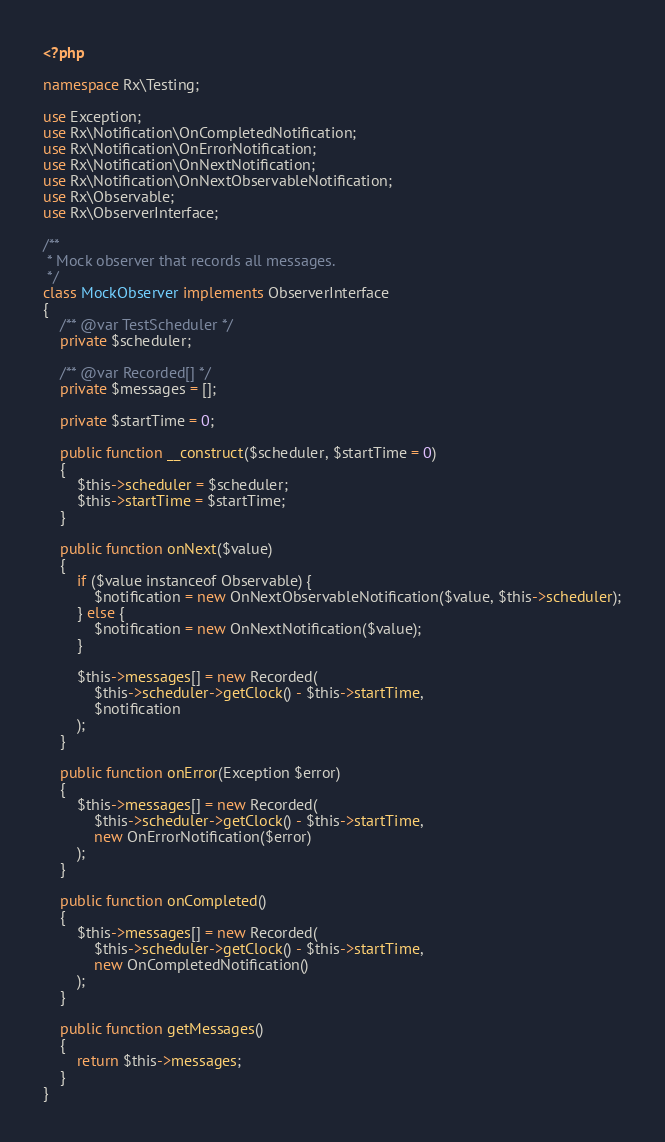<code> <loc_0><loc_0><loc_500><loc_500><_PHP_><?php

namespace Rx\Testing;

use Exception;
use Rx\Notification\OnCompletedNotification;
use Rx\Notification\OnErrorNotification;
use Rx\Notification\OnNextNotification;
use Rx\Notification\OnNextObservableNotification;
use Rx\Observable;
use Rx\ObserverInterface;

/**
 * Mock observer that records all messages.
 */
class MockObserver implements ObserverInterface
{
    /** @var TestScheduler */
    private $scheduler;

    /** @var Recorded[] */
    private $messages = [];

    private $startTime = 0;

    public function __construct($scheduler, $startTime = 0)
    {
        $this->scheduler = $scheduler;
        $this->startTime = $startTime;
    }

    public function onNext($value)
    {
        if ($value instanceof Observable) {
            $notification = new OnNextObservableNotification($value, $this->scheduler);
        } else {
            $notification = new OnNextNotification($value);
        }

        $this->messages[] = new Recorded(
            $this->scheduler->getClock() - $this->startTime,
            $notification
        );
    }

    public function onError(Exception $error)
    {
        $this->messages[] = new Recorded(
            $this->scheduler->getClock() - $this->startTime,
            new OnErrorNotification($error)
        );
    }

    public function onCompleted()
    {
        $this->messages[] = new Recorded(
            $this->scheduler->getClock() - $this->startTime,
            new OnCompletedNotification()
        );
    }

    public function getMessages()
    {
        return $this->messages;
    }
}
</code> 